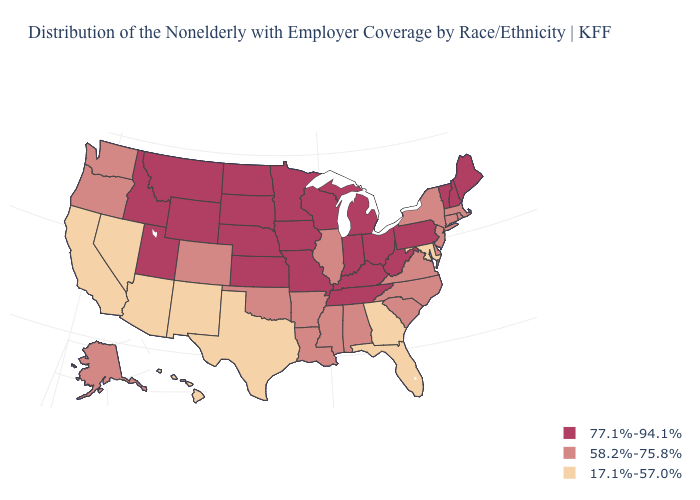Is the legend a continuous bar?
Answer briefly. No. What is the value of Montana?
Write a very short answer. 77.1%-94.1%. What is the value of Nebraska?
Quick response, please. 77.1%-94.1%. Does Maryland have the highest value in the USA?
Keep it brief. No. Name the states that have a value in the range 58.2%-75.8%?
Be succinct. Alabama, Alaska, Arkansas, Colorado, Connecticut, Delaware, Illinois, Louisiana, Massachusetts, Mississippi, New Jersey, New York, North Carolina, Oklahoma, Oregon, Rhode Island, South Carolina, Virginia, Washington. Does Minnesota have the highest value in the USA?
Concise answer only. Yes. Does Rhode Island have the same value as Alaska?
Give a very brief answer. Yes. Is the legend a continuous bar?
Give a very brief answer. No. What is the value of Nevada?
Answer briefly. 17.1%-57.0%. What is the value of Wisconsin?
Be succinct. 77.1%-94.1%. Does Hawaii have the same value as Virginia?
Short answer required. No. Does Maine have the highest value in the Northeast?
Concise answer only. Yes. Name the states that have a value in the range 58.2%-75.8%?
Be succinct. Alabama, Alaska, Arkansas, Colorado, Connecticut, Delaware, Illinois, Louisiana, Massachusetts, Mississippi, New Jersey, New York, North Carolina, Oklahoma, Oregon, Rhode Island, South Carolina, Virginia, Washington. What is the value of Montana?
Be succinct. 77.1%-94.1%. What is the lowest value in states that border North Carolina?
Keep it brief. 17.1%-57.0%. 